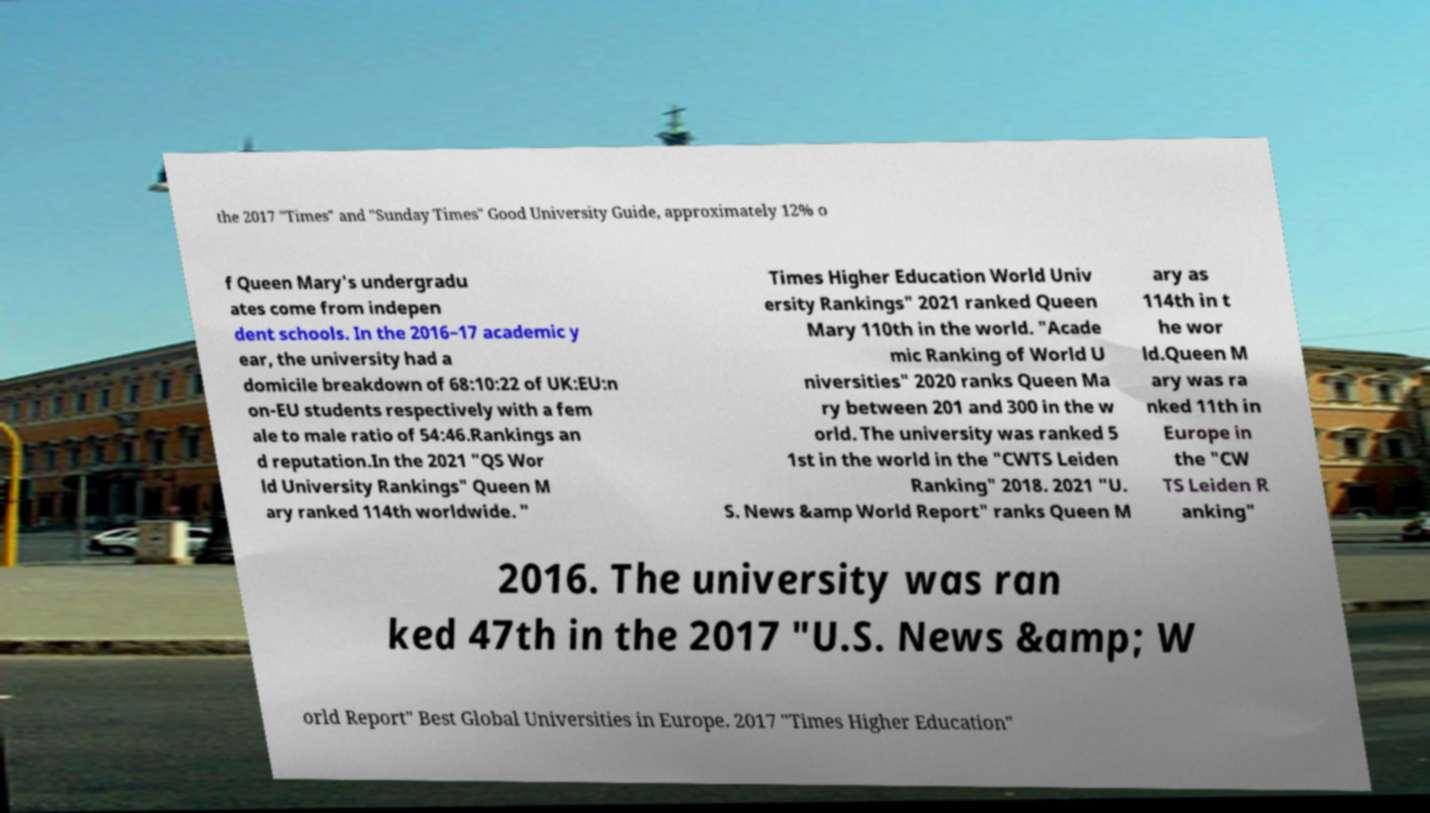I need the written content from this picture converted into text. Can you do that? the 2017 "Times" and "Sunday Times" Good University Guide, approximately 12% o f Queen Mary's undergradu ates come from indepen dent schools. In the 2016–17 academic y ear, the university had a domicile breakdown of 68:10:22 of UK:EU:n on-EU students respectively with a fem ale to male ratio of 54:46.Rankings an d reputation.In the 2021 "QS Wor ld University Rankings" Queen M ary ranked 114th worldwide. " Times Higher Education World Univ ersity Rankings" 2021 ranked Queen Mary 110th in the world. "Acade mic Ranking of World U niversities" 2020 ranks Queen Ma ry between 201 and 300 in the w orld. The university was ranked 5 1st in the world in the "CWTS Leiden Ranking" 2018. 2021 "U. S. News &amp World Report" ranks Queen M ary as 114th in t he wor ld.Queen M ary was ra nked 11th in Europe in the "CW TS Leiden R anking" 2016. The university was ran ked 47th in the 2017 "U.S. News &amp; W orld Report" Best Global Universities in Europe. 2017 "Times Higher Education" 